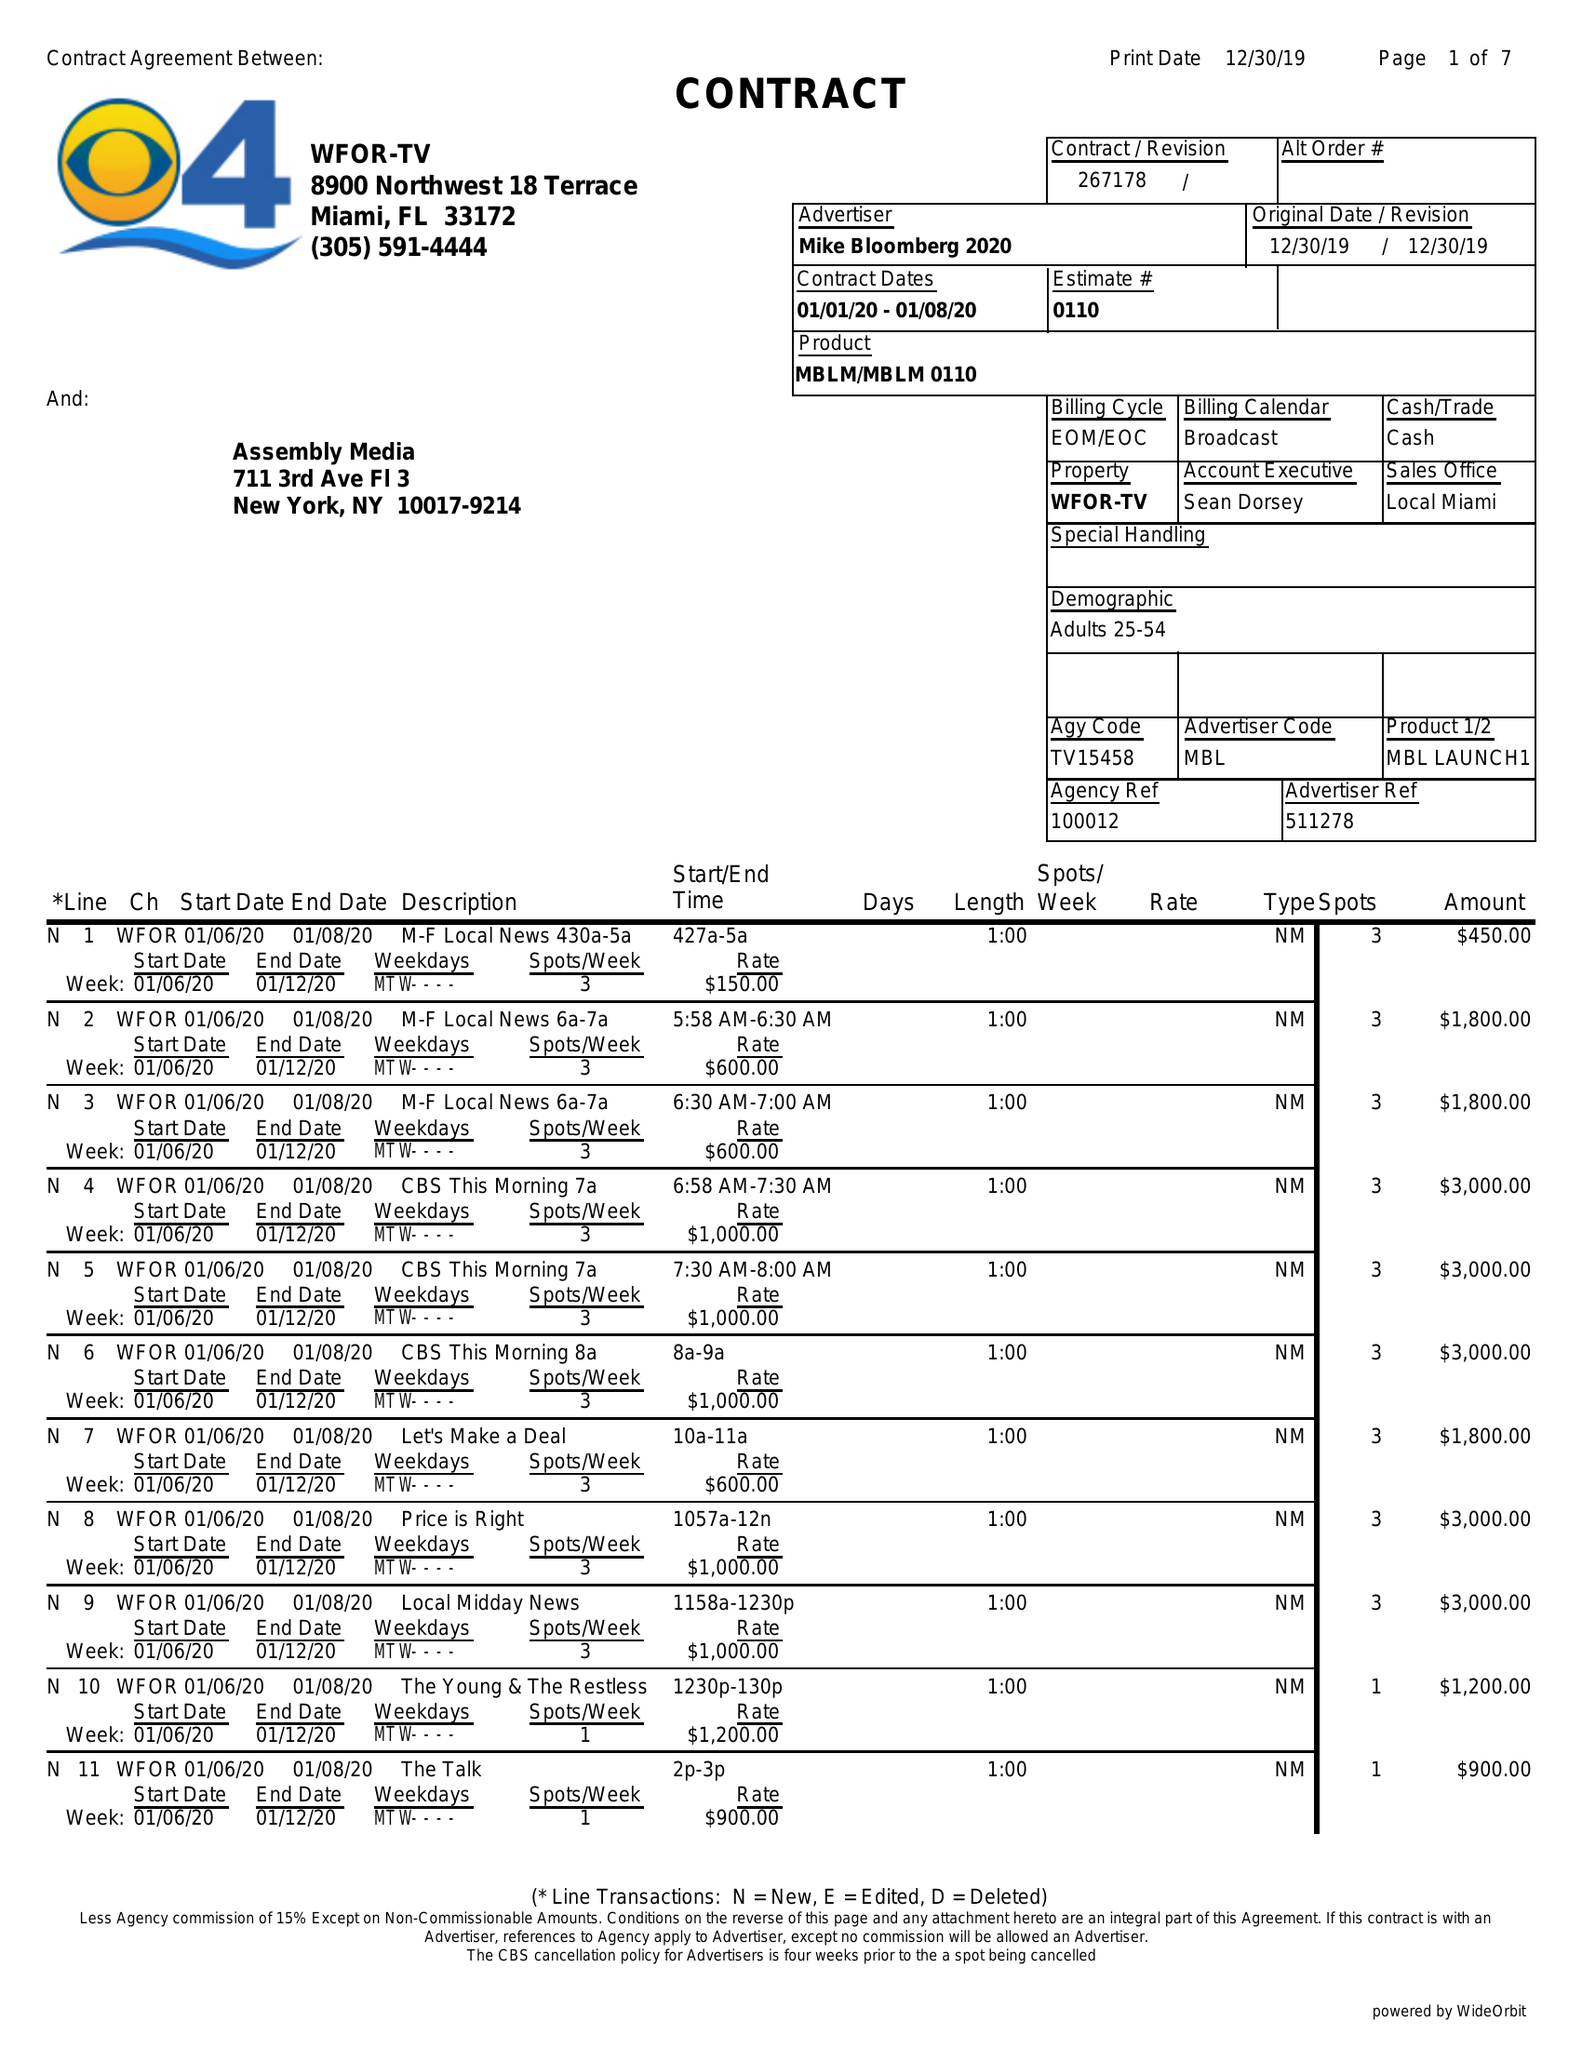What is the value for the flight_from?
Answer the question using a single word or phrase. 01/01/20 